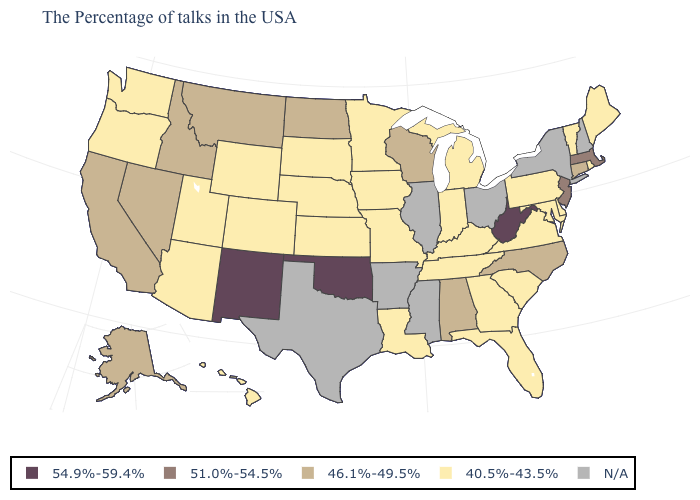Name the states that have a value in the range 54.9%-59.4%?
Write a very short answer. West Virginia, Oklahoma, New Mexico. How many symbols are there in the legend?
Give a very brief answer. 5. Which states have the lowest value in the Northeast?
Quick response, please. Maine, Rhode Island, Vermont, Pennsylvania. What is the value of Nebraska?
Give a very brief answer. 40.5%-43.5%. Does the first symbol in the legend represent the smallest category?
Concise answer only. No. Among the states that border North Dakota , which have the lowest value?
Quick response, please. Minnesota, South Dakota. What is the value of Wyoming?
Quick response, please. 40.5%-43.5%. Does the first symbol in the legend represent the smallest category?
Write a very short answer. No. Name the states that have a value in the range N/A?
Write a very short answer. New Hampshire, New York, Ohio, Illinois, Mississippi, Arkansas, Texas. Does New Jersey have the highest value in the Northeast?
Concise answer only. Yes. Name the states that have a value in the range N/A?
Write a very short answer. New Hampshire, New York, Ohio, Illinois, Mississippi, Arkansas, Texas. What is the value of Utah?
Be succinct. 40.5%-43.5%. What is the lowest value in the South?
Concise answer only. 40.5%-43.5%. What is the value of Arizona?
Short answer required. 40.5%-43.5%. Which states hav the highest value in the MidWest?
Quick response, please. Wisconsin, North Dakota. 